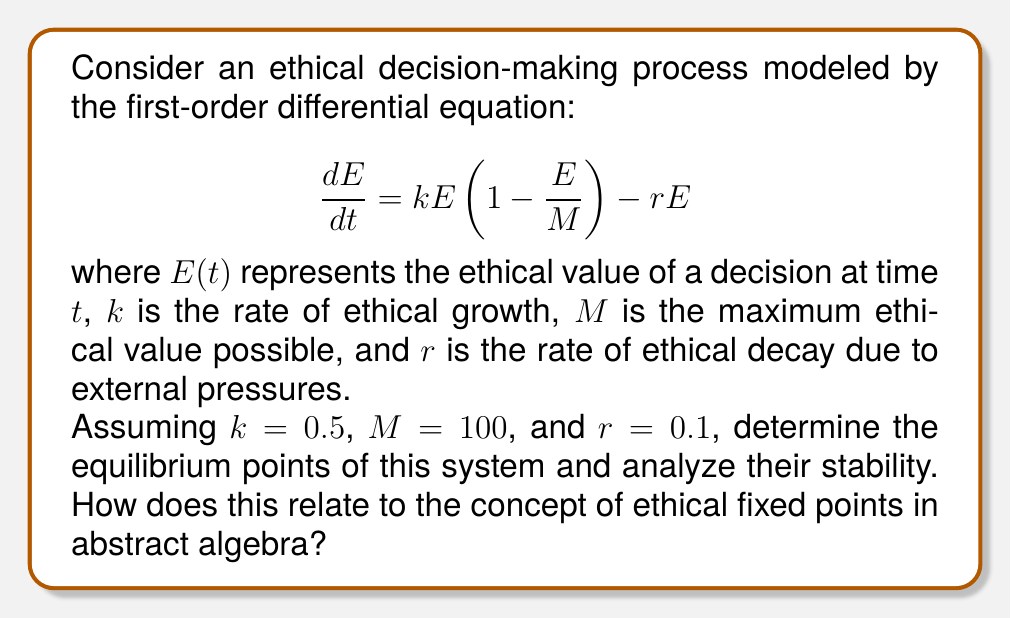Give your solution to this math problem. To solve this problem, we'll follow these steps:

1) First, let's identify the equilibrium points by setting $\frac{dE}{dt} = 0$:

   $$ 0 = kE(1-\frac{E}{M}) - rE $$
   $$ 0 = 0.5E(1-\frac{E}{100}) - 0.1E $$

2) Factoring out $E$:

   $$ 0 = E(0.5(1-\frac{E}{100}) - 0.1) $$
   $$ 0 = E(0.5 - 0.005E - 0.1) $$
   $$ 0 = E(0.4 - 0.005E) $$

3) Solving this equation:
   
   Either $E = 0$ or $0.4 - 0.005E = 0$
   
   From the second equation: $E = 80$

4) So, our equilibrium points are $E = 0$ and $E = 80$.

5) To analyze stability, we need to look at the derivative of $\frac{dE}{dt}$ with respect to $E$ at each equilibrium point:

   $$ \frac{d}{dE}(\frac{dE}{dt}) = k(1-\frac{2E}{M}) - r $$
   $$ = 0.5(1-\frac{2E}{100}) - 0.1 $$
   $$ = 0.5 - 0.01E - 0.1 $$
   $$ = 0.4 - 0.01E $$

6) At $E = 0$:
   $0.4 - 0.01(0) = 0.4 > 0$, so this is an unstable equilibrium.

   At $E = 80$:
   $0.4 - 0.01(80) = -0.4 < 0$, so this is a stable equilibrium.

This model relates to abstract algebra through the concept of fixed points. In abstract algebra, a fixed point is an element that is mapped to itself by a function. Here, the equilibrium points are analogous to fixed points in the continuous dynamical system described by our differential equation.

The stable equilibrium at $E = 80$ represents an ethical fixed point towards which decisions tend to converge over time, while the unstable equilibrium at $E = 0$ represents a threshold below which ethical value tends to degrade to zero.
Answer: The system has two equilibrium points: $E = 0$ (unstable) and $E = 80$ (stable). The stable equilibrium at $E = 80$ represents an ethical fixed point in the decision-making process. 